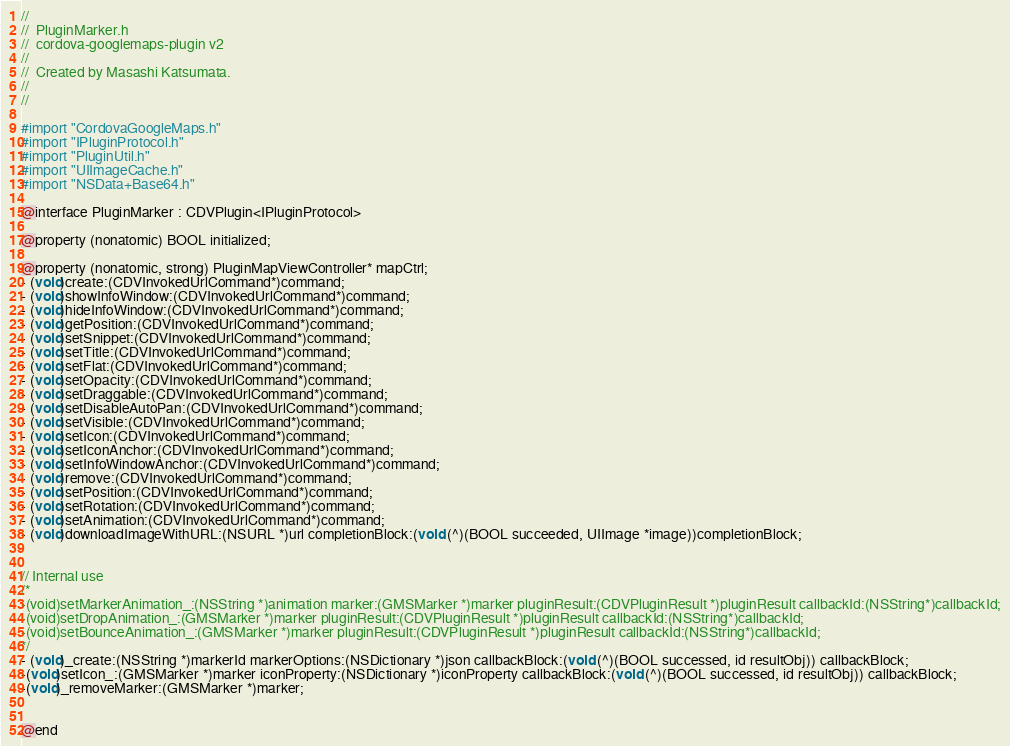<code> <loc_0><loc_0><loc_500><loc_500><_C_>//
//  PluginMarker.h
//  cordova-googlemaps-plugin v2
//
//  Created by Masashi Katsumata.
//
//

#import "CordovaGoogleMaps.h"
#import "IPluginProtocol.h"
#import "PluginUtil.h"
#import "UIImageCache.h"
#import "NSData+Base64.h"

@interface PluginMarker : CDVPlugin<IPluginProtocol>

@property (nonatomic) BOOL initialized;

@property (nonatomic, strong) PluginMapViewController* mapCtrl;
- (void)create:(CDVInvokedUrlCommand*)command;
- (void)showInfoWindow:(CDVInvokedUrlCommand*)command;
- (void)hideInfoWindow:(CDVInvokedUrlCommand*)command;
- (void)getPosition:(CDVInvokedUrlCommand*)command;
- (void)setSnippet:(CDVInvokedUrlCommand*)command;
- (void)setTitle:(CDVInvokedUrlCommand*)command;
- (void)setFlat:(CDVInvokedUrlCommand*)command;
- (void)setOpacity:(CDVInvokedUrlCommand*)command;
- (void)setDraggable:(CDVInvokedUrlCommand*)command;
- (void)setDisableAutoPan:(CDVInvokedUrlCommand*)command;
- (void)setVisible:(CDVInvokedUrlCommand*)command;
- (void)setIcon:(CDVInvokedUrlCommand*)command;
- (void)setIconAnchor:(CDVInvokedUrlCommand*)command;
- (void)setInfoWindowAnchor:(CDVInvokedUrlCommand*)command;
- (void)remove:(CDVInvokedUrlCommand*)command;
- (void)setPosition:(CDVInvokedUrlCommand*)command;
- (void)setRotation:(CDVInvokedUrlCommand*)command;
- (void)setAnimation:(CDVInvokedUrlCommand*)command;
- (void)downloadImageWithURL:(NSURL *)url completionBlock:(void (^)(BOOL succeeded, UIImage *image))completionBlock;


// Internal use
/*
-(void)setMarkerAnimation_:(NSString *)animation marker:(GMSMarker *)marker pluginResult:(CDVPluginResult *)pluginResult callbackId:(NSString*)callbackId;
-(void)setDropAnimation_:(GMSMarker *)marker pluginResult:(CDVPluginResult *)pluginResult callbackId:(NSString*)callbackId;
-(void)setBounceAnimation_:(GMSMarker *)marker pluginResult:(CDVPluginResult *)pluginResult callbackId:(NSString*)callbackId;
*/
- (void)_create:(NSString *)markerId markerOptions:(NSDictionary *)json callbackBlock:(void (^)(BOOL successed, id resultObj)) callbackBlock;
-(void)setIcon_:(GMSMarker *)marker iconProperty:(NSDictionary *)iconProperty callbackBlock:(void (^)(BOOL successed, id resultObj)) callbackBlock;
-(void)_removeMarker:(GMSMarker *)marker;


@end
</code> 